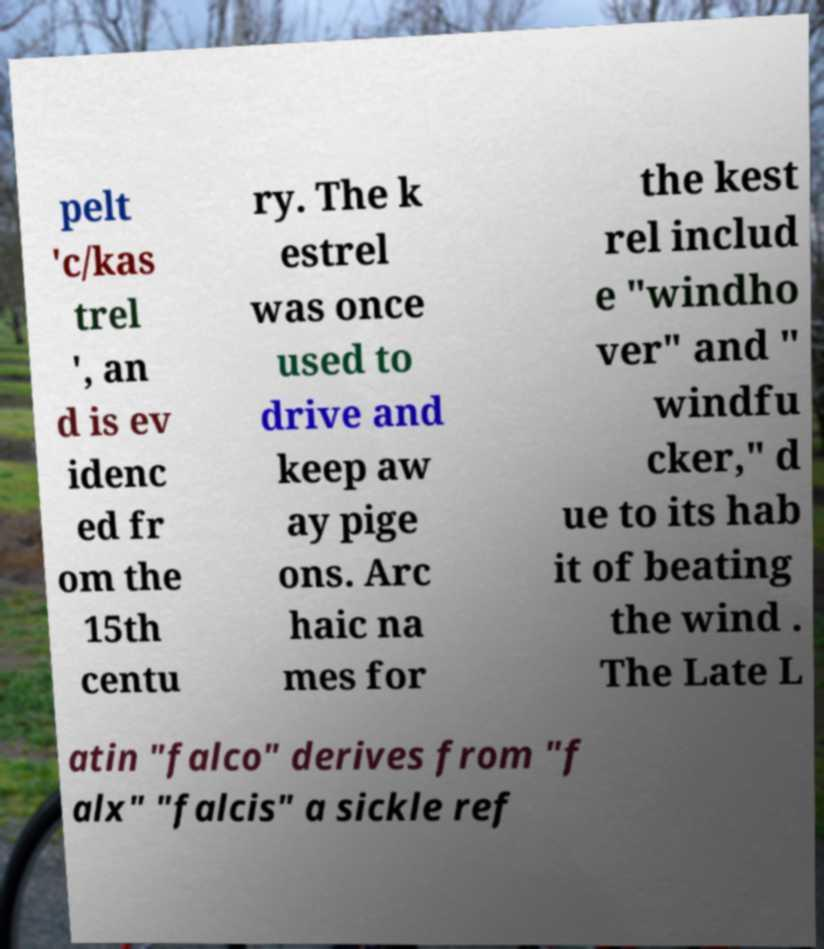Can you accurately transcribe the text from the provided image for me? pelt 'c/kas trel ', an d is ev idenc ed fr om the 15th centu ry. The k estrel was once used to drive and keep aw ay pige ons. Arc haic na mes for the kest rel includ e "windho ver" and " windfu cker," d ue to its hab it of beating the wind . The Late L atin "falco" derives from "f alx" "falcis" a sickle ref 